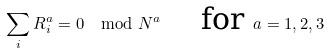<formula> <loc_0><loc_0><loc_500><loc_500>\sum _ { i } R _ { i } ^ { a } = 0 \mod N ^ { a } \quad \text { for } a = 1 , 2 , 3</formula> 